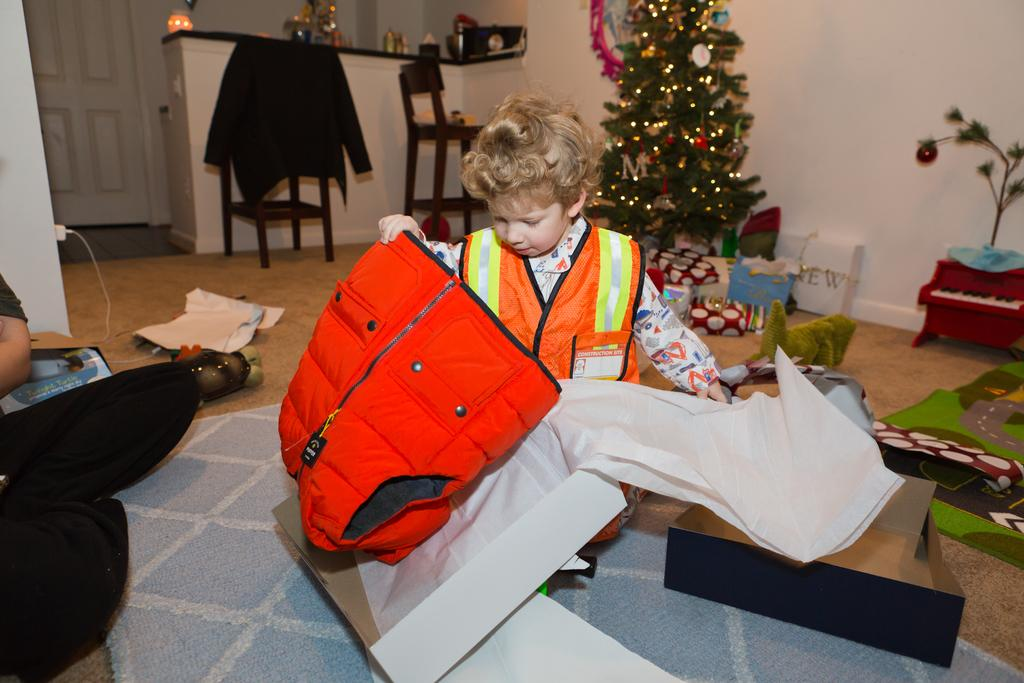Who is present in the image? There is a boy in the image. What is the boy wearing? The boy is wearing a safety dress. What is the boy holding? The boy is holding a red jacket. What can be seen in the background of the image? There is a Christmas tree, a chair, and a wall in the background. How many clovers can be seen on the wall in the image? There are no clovers present in the image; the wall is part of the background and does not have any clovers. 